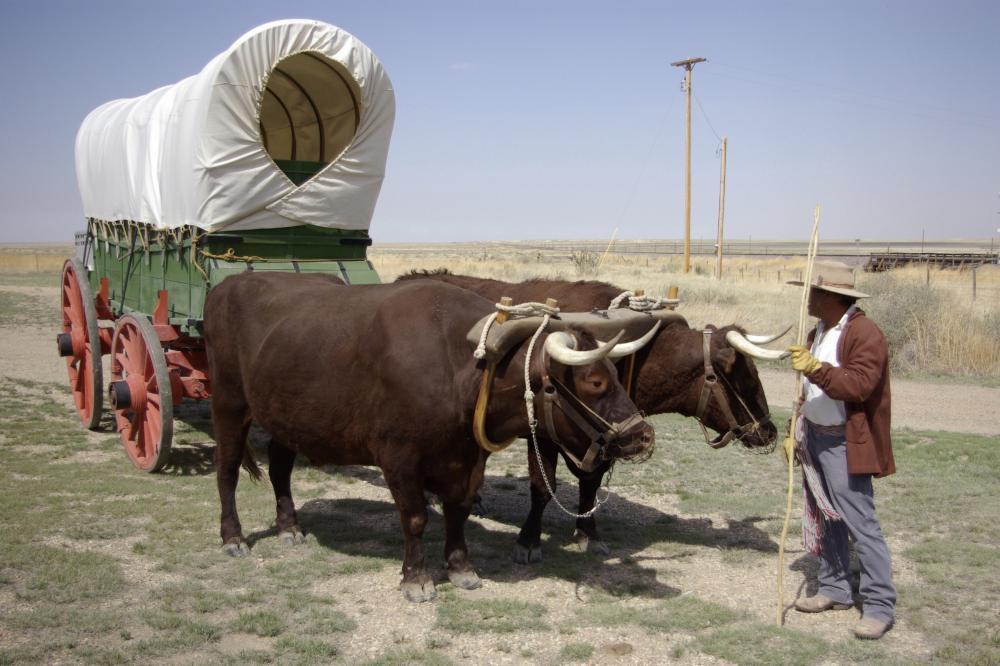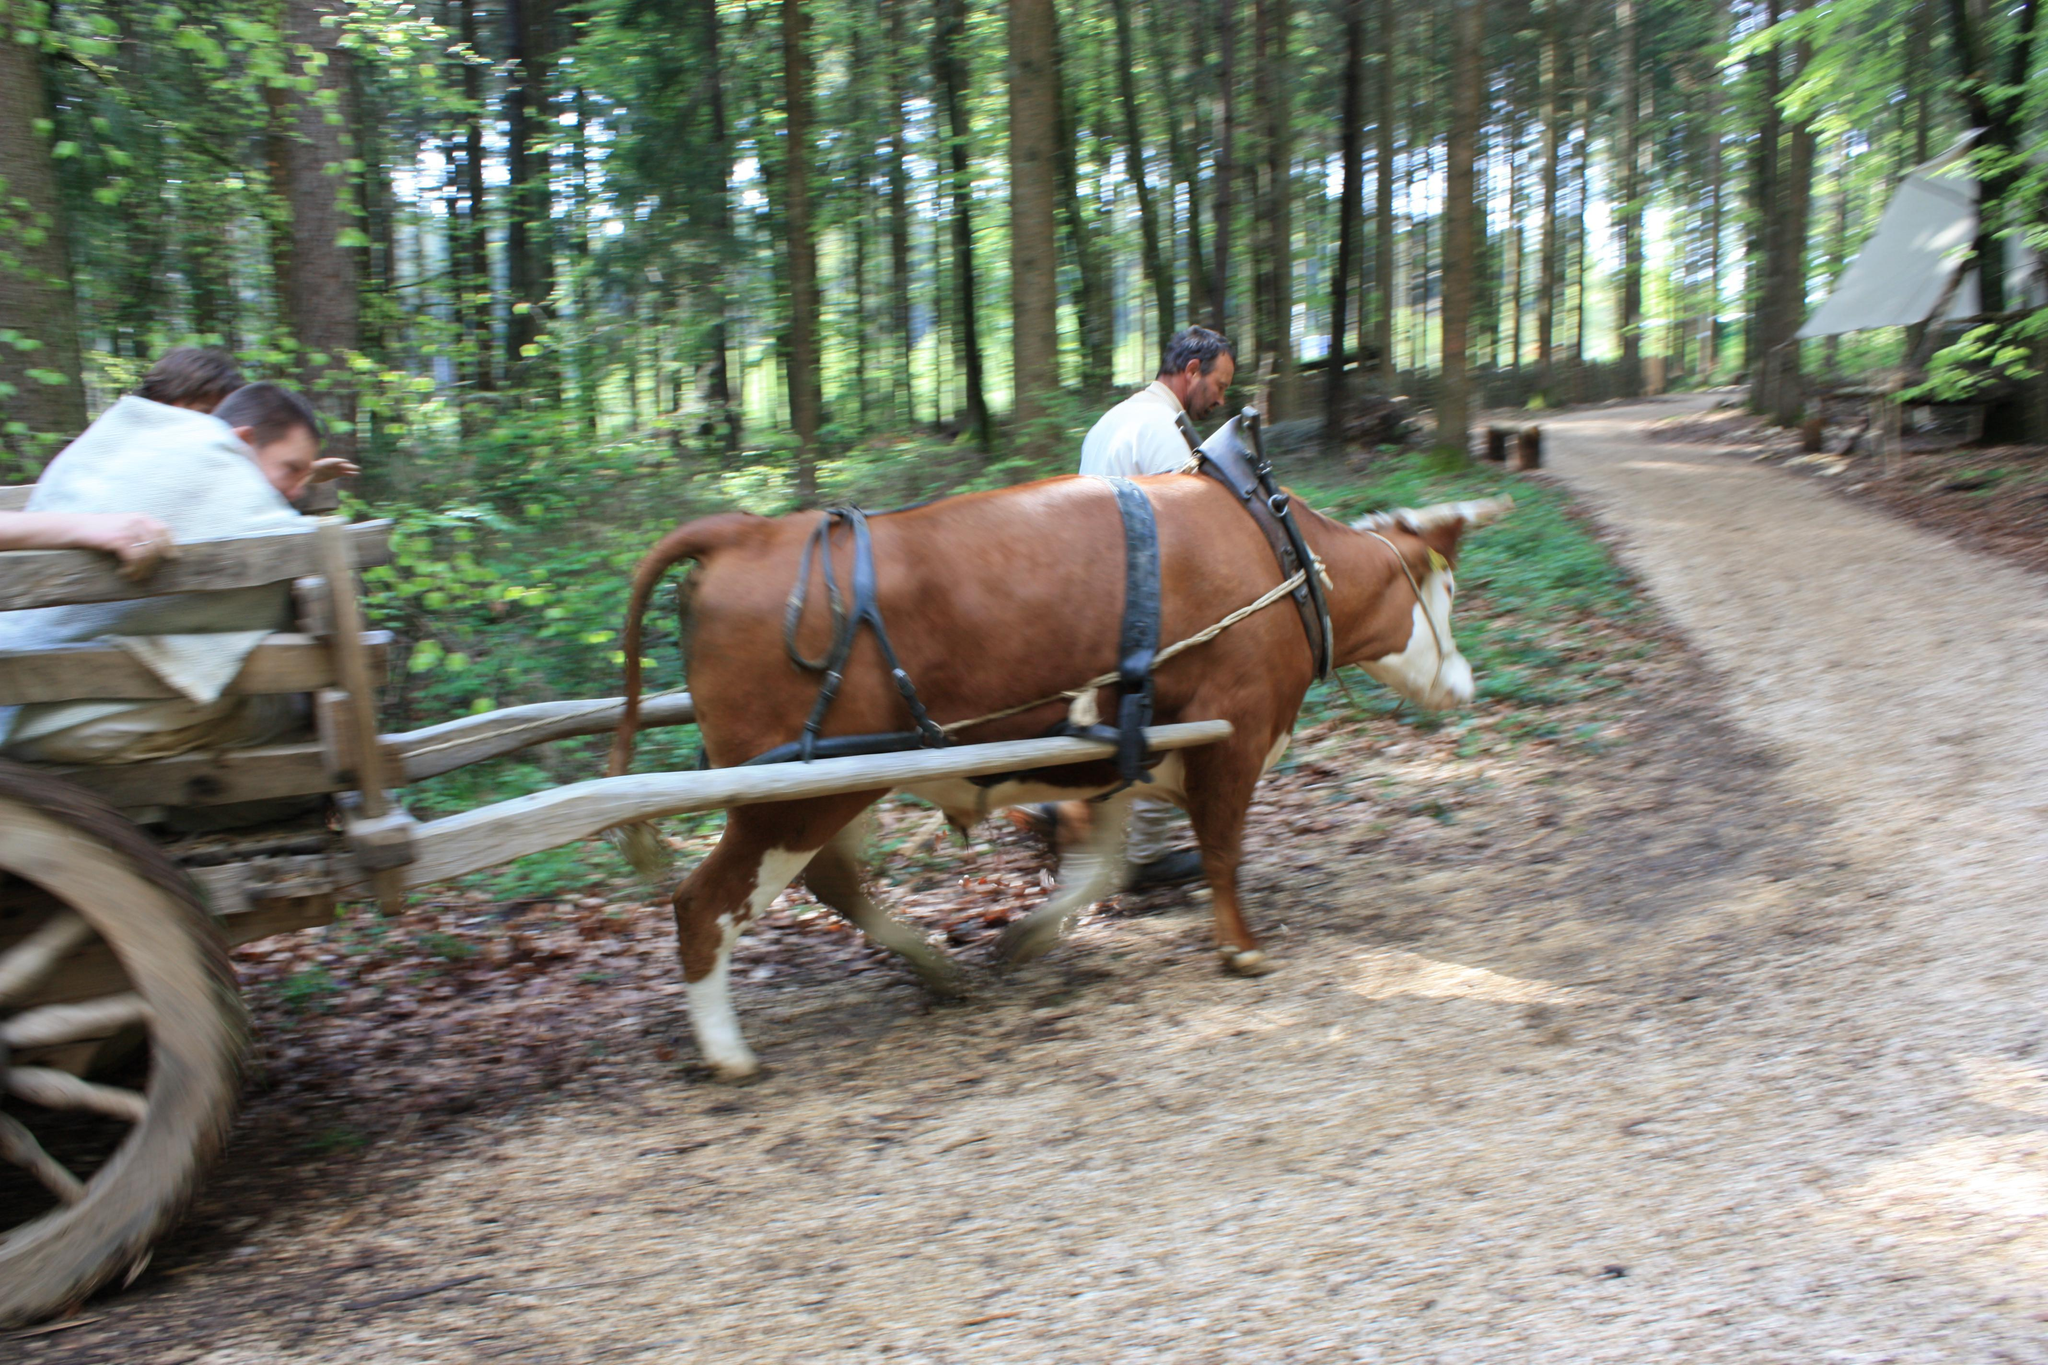The first image is the image on the left, the second image is the image on the right. Analyze the images presented: Is the assertion "In the image to the left we've got two work-animals." valid? Answer yes or no. Yes. The first image is the image on the left, the second image is the image on the right. Assess this claim about the two images: "An image shows all brown oxen hitched to a green covered wagon with red wheels and aimed rightward.". Correct or not? Answer yes or no. Yes. 